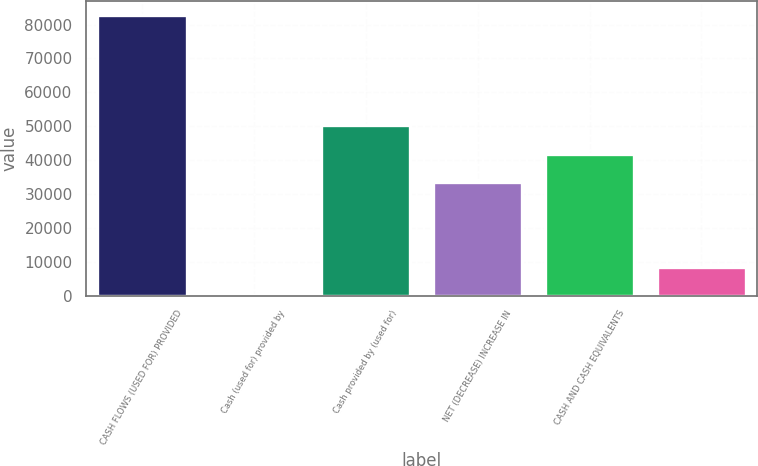Convert chart. <chart><loc_0><loc_0><loc_500><loc_500><bar_chart><fcel>CASH FLOWS (USED FOR) PROVIDED<fcel>Cash (used for) provided by<fcel>Cash provided by (used for)<fcel>NET (DECREASE) INCREASE IN<fcel>CASH AND CASH EQUIVALENTS<fcel>Unnamed: 5<nl><fcel>82965<fcel>263<fcel>50223.4<fcel>33683<fcel>41953.2<fcel>8533.2<nl></chart> 